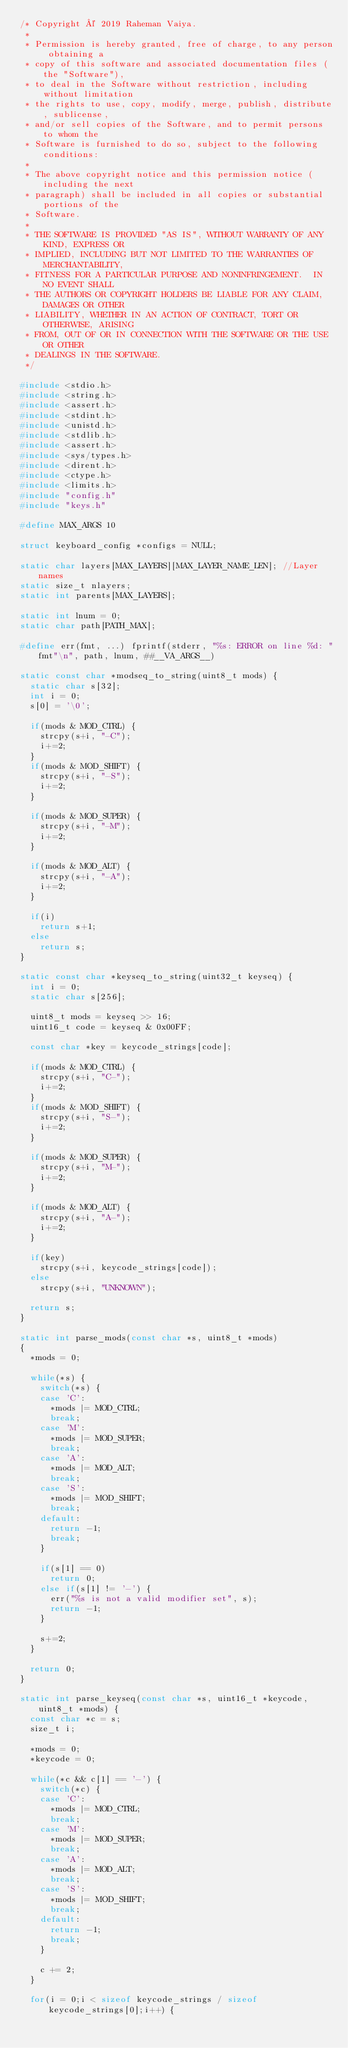Convert code to text. <code><loc_0><loc_0><loc_500><loc_500><_C_>/* Copyright © 2019 Raheman Vaiya.
 *
 * Permission is hereby granted, free of charge, to any person obtaining a
 * copy of this software and associated documentation files (the "Software"),
 * to deal in the Software without restriction, including without limitation
 * the rights to use, copy, modify, merge, publish, distribute, sublicense,
 * and/or sell copies of the Software, and to permit persons to whom the
 * Software is furnished to do so, subject to the following conditions:
 *
 * The above copyright notice and this permission notice (including the next
 * paragraph) shall be included in all copies or substantial portions of the
 * Software.
 *
 * THE SOFTWARE IS PROVIDED "AS IS", WITHOUT WARRANTY OF ANY KIND, EXPRESS OR
 * IMPLIED, INCLUDING BUT NOT LIMITED TO THE WARRANTIES OF MERCHANTABILITY,
 * FITNESS FOR A PARTICULAR PURPOSE AND NONINFRINGEMENT.  IN NO EVENT SHALL
 * THE AUTHORS OR COPYRIGHT HOLDERS BE LIABLE FOR ANY CLAIM, DAMAGES OR OTHER
 * LIABILITY, WHETHER IN AN ACTION OF CONTRACT, TORT OR OTHERWISE, ARISING
 * FROM, OUT OF OR IN CONNECTION WITH THE SOFTWARE OR THE USE OR OTHER
 * DEALINGS IN THE SOFTWARE.
 */

#include <stdio.h>
#include <string.h>
#include <assert.h>
#include <stdint.h>
#include <unistd.h>
#include <stdlib.h>
#include <assert.h>
#include <sys/types.h>
#include <dirent.h>
#include <ctype.h>
#include <limits.h>
#include "config.h"
#include "keys.h"

#define MAX_ARGS 10

struct keyboard_config *configs = NULL;

static char layers[MAX_LAYERS][MAX_LAYER_NAME_LEN]; //Layer names
static size_t nlayers;
static int parents[MAX_LAYERS];

static int lnum = 0;
static char path[PATH_MAX];

#define err(fmt, ...) fprintf(stderr, "%s: ERROR on line %d: "fmt"\n", path, lnum, ##__VA_ARGS__)

static const char *modseq_to_string(uint8_t mods) {
	static char s[32];
	int i = 0;
	s[0] = '\0';

	if(mods & MOD_CTRL) {
		strcpy(s+i, "-C");
		i+=2;
	} 
	if(mods & MOD_SHIFT) {
		strcpy(s+i, "-S");
		i+=2;
	}

	if(mods & MOD_SUPER) {
		strcpy(s+i, "-M");
		i+=2;
	} 

	if(mods & MOD_ALT) {
		strcpy(s+i, "-A");
		i+=2;
	}

	if(i)
		return s+1;
	else
		return s;
}

static const char *keyseq_to_string(uint32_t keyseq) {
	int i = 0;
	static char s[256];

	uint8_t mods = keyseq >> 16;
	uint16_t code = keyseq & 0x00FF;

	const char *key = keycode_strings[code];

	if(mods & MOD_CTRL) {
		strcpy(s+i, "C-");
		i+=2;
	} 
	if(mods & MOD_SHIFT) {
		strcpy(s+i, "S-");
		i+=2;
	}

	if(mods & MOD_SUPER) {
		strcpy(s+i, "M-");
		i+=2;
	} 

	if(mods & MOD_ALT) {
		strcpy(s+i, "A-");
		i+=2;
	}

	if(key)
		strcpy(s+i, keycode_strings[code]);
	else
		strcpy(s+i, "UNKNOWN");

	return s;
}

static int parse_mods(const char *s, uint8_t *mods) 
{
	*mods = 0;

	while(*s) {
		switch(*s) {
		case 'C':
			*mods |= MOD_CTRL;
			break;
		case 'M':
			*mods |= MOD_SUPER;
			break;
		case 'A':
			*mods |= MOD_ALT;
			break;
		case 'S':
			*mods |= MOD_SHIFT;
			break;
		default:
			return -1;
			break;
		}

		if(s[1] == 0)
			return 0;
		else if(s[1] != '-') {
			err("%s is not a valid modifier set", s);
			return -1;
		}

		s+=2;
	}

	return 0;
}

static int parse_keyseq(const char *s, uint16_t *keycode, uint8_t *mods) {
	const char *c = s;
	size_t i;

	*mods = 0;
	*keycode = 0;

	while(*c && c[1] == '-') {
		switch(*c) {
		case 'C':
			*mods |= MOD_CTRL;
			break;
		case 'M':
			*mods |= MOD_SUPER;
			break;
		case 'A':
			*mods |= MOD_ALT;
			break;
		case 'S':
			*mods |= MOD_SHIFT;
			break;
		default:
			return -1;
			break;
		}

		c += 2;
	}

	for(i = 0;i < sizeof keycode_strings / sizeof keycode_strings[0];i++) {</code> 